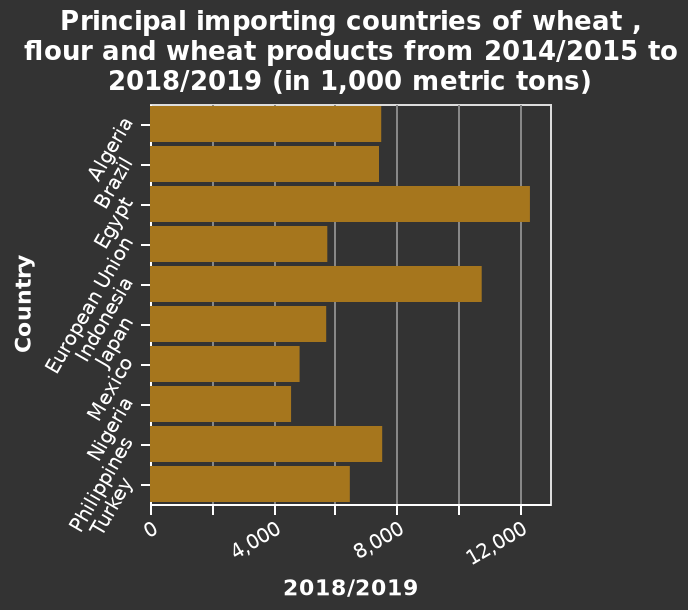<image>
Offer a thorough analysis of the image. Egypt imported most wheat according to the chart visualising principal importing countries of wheat , flour and wheat products from 2014/2015 to 2018/2019. Egypt imported over 12 000 metric tons of wheat.  The lowest importer is Nigeria with 5000 metric tons of wheat. 